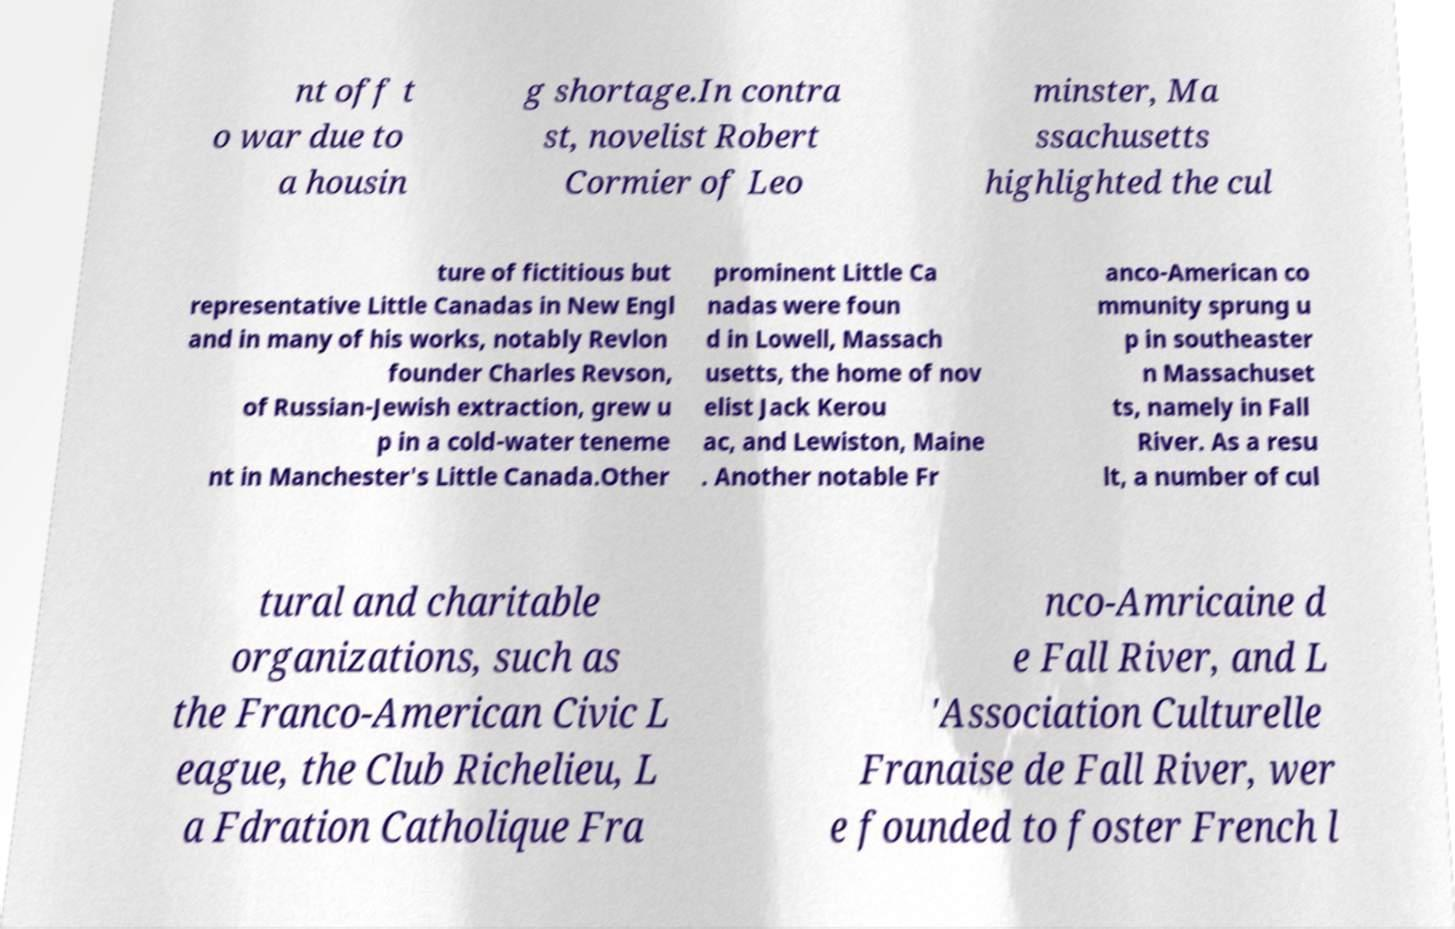Please read and relay the text visible in this image. What does it say? nt off t o war due to a housin g shortage.In contra st, novelist Robert Cormier of Leo minster, Ma ssachusetts highlighted the cul ture of fictitious but representative Little Canadas in New Engl and in many of his works, notably Revlon founder Charles Revson, of Russian-Jewish extraction, grew u p in a cold-water teneme nt in Manchester's Little Canada.Other prominent Little Ca nadas were foun d in Lowell, Massach usetts, the home of nov elist Jack Kerou ac, and Lewiston, Maine . Another notable Fr anco-American co mmunity sprung u p in southeaster n Massachuset ts, namely in Fall River. As a resu lt, a number of cul tural and charitable organizations, such as the Franco-American Civic L eague, the Club Richelieu, L a Fdration Catholique Fra nco-Amricaine d e Fall River, and L 'Association Culturelle Franaise de Fall River, wer e founded to foster French l 